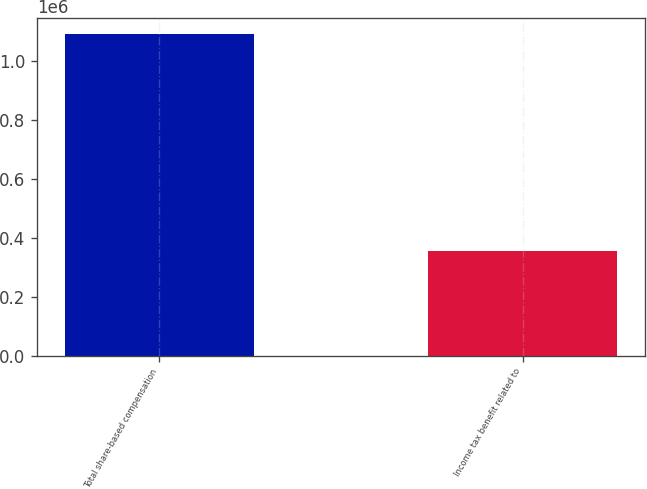Convert chart to OTSL. <chart><loc_0><loc_0><loc_500><loc_500><bar_chart><fcel>Total share-based compensation<fcel>Income tax benefit related to<nl><fcel>1.09325e+06<fcel>356062<nl></chart> 